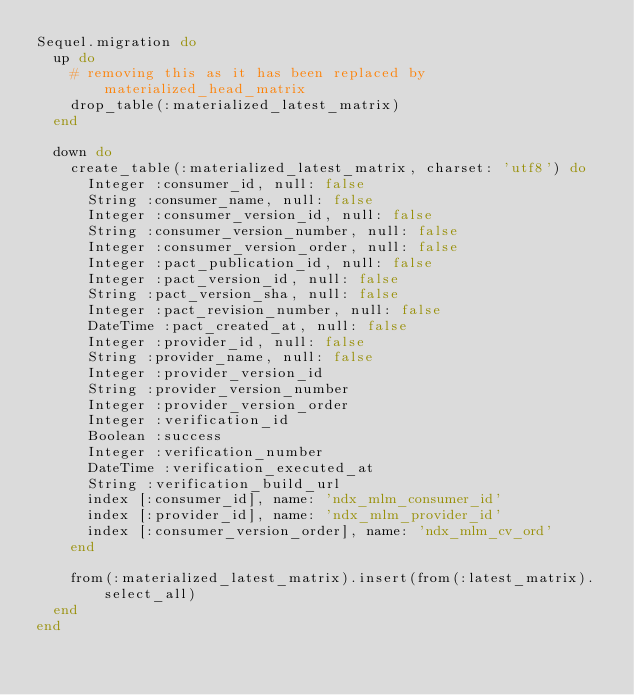Convert code to text. <code><loc_0><loc_0><loc_500><loc_500><_Ruby_>Sequel.migration do
  up do
    # removing this as it has been replaced by materialized_head_matrix
    drop_table(:materialized_latest_matrix)
  end

  down do
    create_table(:materialized_latest_matrix, charset: 'utf8') do
      Integer :consumer_id, null: false
      String :consumer_name, null: false
      Integer :consumer_version_id, null: false
      String :consumer_version_number, null: false
      Integer :consumer_version_order, null: false
      Integer :pact_publication_id, null: false
      Integer :pact_version_id, null: false
      String :pact_version_sha, null: false
      Integer :pact_revision_number, null: false
      DateTime :pact_created_at, null: false
      Integer :provider_id, null: false
      String :provider_name, null: false
      Integer :provider_version_id
      String :provider_version_number
      Integer :provider_version_order
      Integer :verification_id
      Boolean :success
      Integer :verification_number
      DateTime :verification_executed_at
      String :verification_build_url
      index [:consumer_id], name: 'ndx_mlm_consumer_id'
      index [:provider_id], name: 'ndx_mlm_provider_id'
      index [:consumer_version_order], name: 'ndx_mlm_cv_ord'
    end

    from(:materialized_latest_matrix).insert(from(:latest_matrix).select_all)
  end
end
</code> 